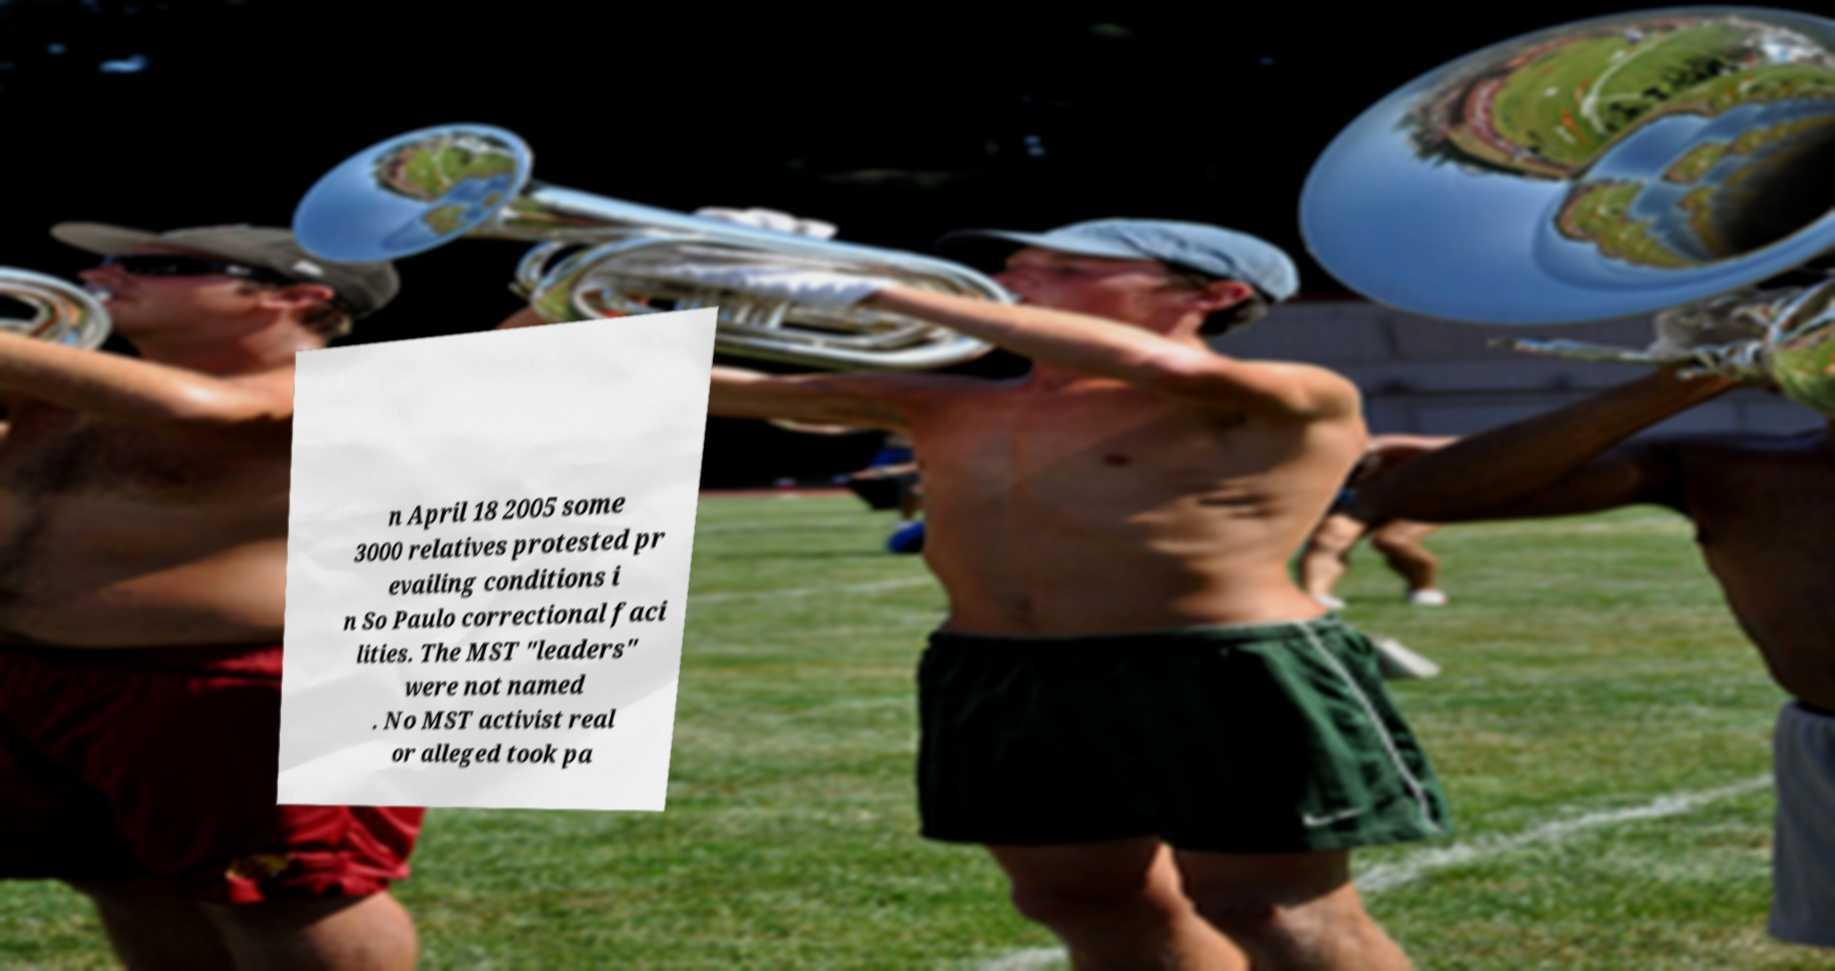I need the written content from this picture converted into text. Can you do that? n April 18 2005 some 3000 relatives protested pr evailing conditions i n So Paulo correctional faci lities. The MST "leaders" were not named . No MST activist real or alleged took pa 